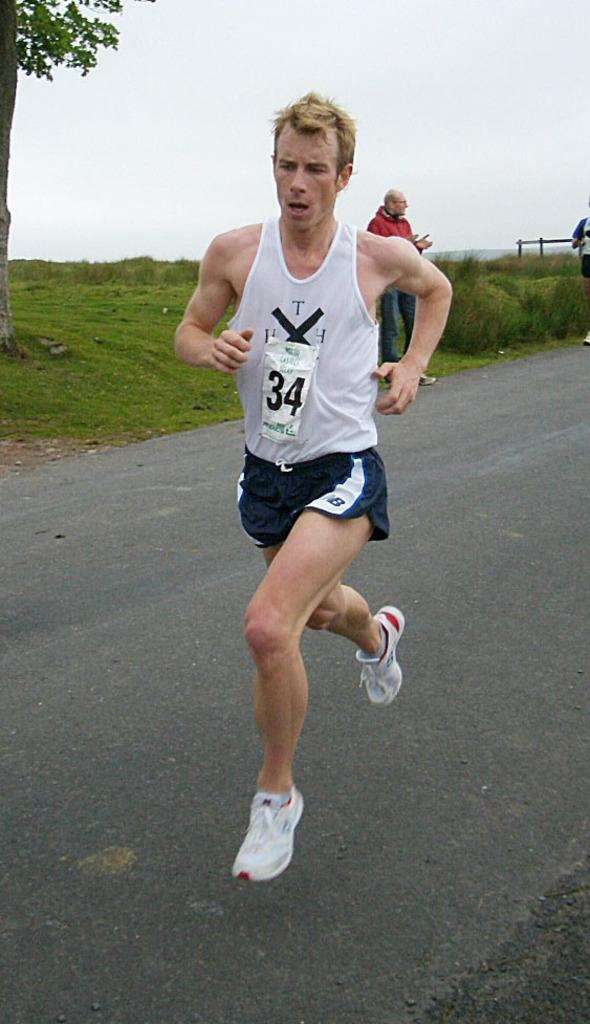What is the man in the image doing? The man in the image is running on the road. Are there any other people in the image? Yes, there are two persons behind the man in the image. What type of vegetation can be seen in the image? There is grass visible in the image. What is visible in the background of the image? There is a tree and the sky visible in the background of the image. What arithmetic problem is the man solving while running in the image? There is no indication in the image that the man is solving an arithmetic problem while running. What type of skin condition can be seen on the man's face in the image? There is no skin condition visible on the man's face in the image. 